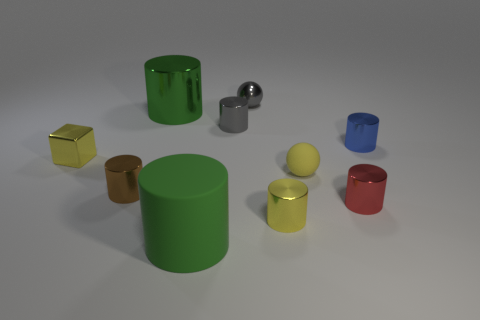Subtract all gray cylinders. How many cylinders are left? 6 Subtract 2 cylinders. How many cylinders are left? 5 Subtract all small brown cylinders. How many cylinders are left? 6 Subtract all cyan cylinders. Subtract all red spheres. How many cylinders are left? 7 Subtract all balls. How many objects are left? 8 Subtract 0 purple spheres. How many objects are left? 10 Subtract all blue metal cylinders. Subtract all tiny red metallic objects. How many objects are left? 8 Add 7 tiny brown cylinders. How many tiny brown cylinders are left? 8 Add 9 green shiny things. How many green shiny things exist? 10 